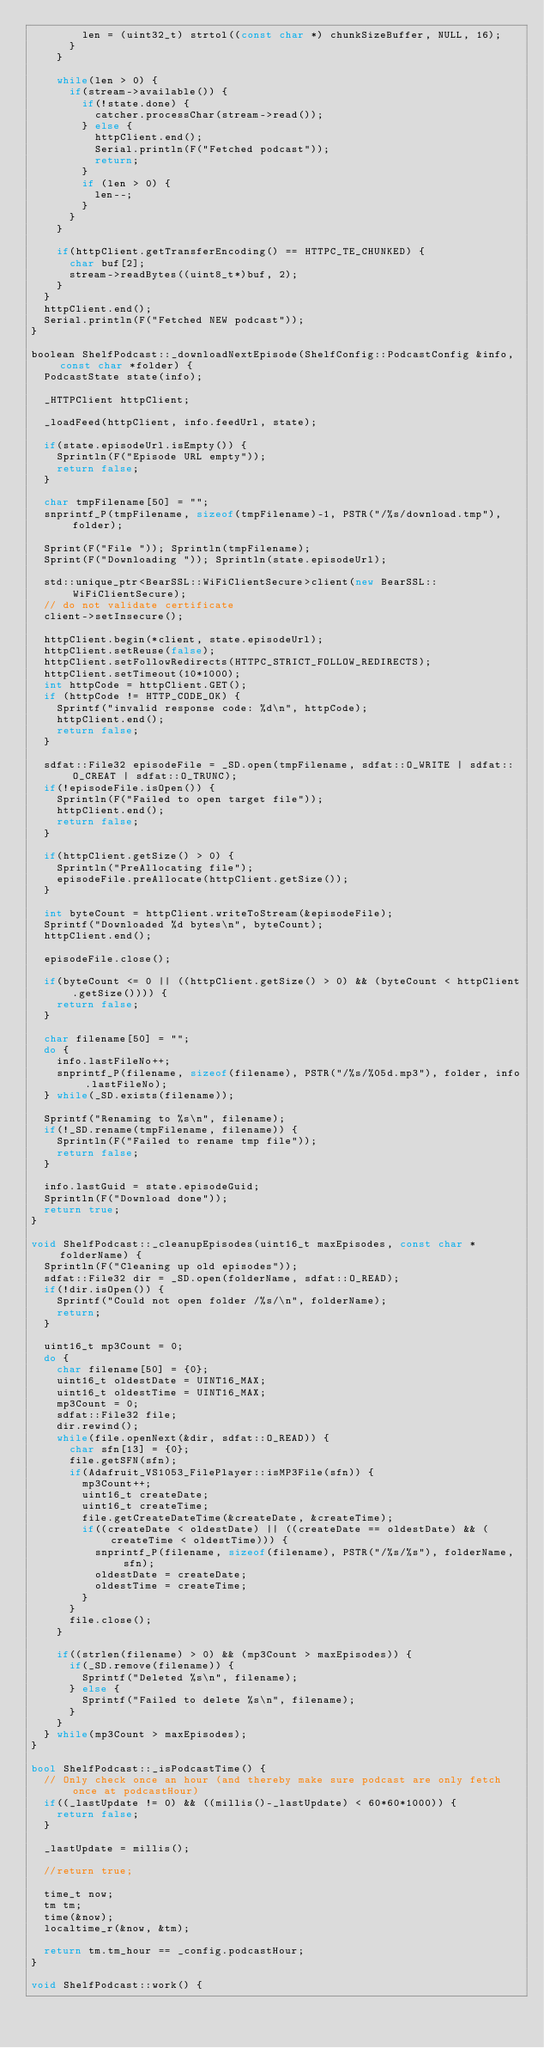Convert code to text. <code><loc_0><loc_0><loc_500><loc_500><_C++_>        len = (uint32_t) strtol((const char *) chunkSizeBuffer, NULL, 16);
      }
    }

    while(len > 0) {
      if(stream->available()) {
        if(!state.done) {
          catcher.processChar(stream->read());
        } else {
          httpClient.end();
          Serial.println(F("Fetched podcast"));
          return;
        }
        if (len > 0) {
          len--;
        }
      }
    }

    if(httpClient.getTransferEncoding() == HTTPC_TE_CHUNKED) {
      char buf[2];
      stream->readBytes((uint8_t*)buf, 2);
    }
  }
  httpClient.end();
  Serial.println(F("Fetched NEW podcast"));
}

boolean ShelfPodcast::_downloadNextEpisode(ShelfConfig::PodcastConfig &info, const char *folder) {
  PodcastState state(info);

  _HTTPClient httpClient;

  _loadFeed(httpClient, info.feedUrl, state);

  if(state.episodeUrl.isEmpty()) {
    Sprintln(F("Episode URL empty"));
    return false;
  }

  char tmpFilename[50] = "";
  snprintf_P(tmpFilename, sizeof(tmpFilename)-1, PSTR("/%s/download.tmp"), folder);

  Sprint(F("File ")); Sprintln(tmpFilename);
  Sprint(F("Downloading ")); Sprintln(state.episodeUrl);

  std::unique_ptr<BearSSL::WiFiClientSecure>client(new BearSSL::WiFiClientSecure);
  // do not validate certificate
  client->setInsecure();

  httpClient.begin(*client, state.episodeUrl);
  httpClient.setReuse(false);
  httpClient.setFollowRedirects(HTTPC_STRICT_FOLLOW_REDIRECTS);
  httpClient.setTimeout(10*1000);
  int httpCode = httpClient.GET();
  if (httpCode != HTTP_CODE_OK) {
    Sprintf("invalid response code: %d\n", httpCode);
    httpClient.end();
    return false;
  }

  sdfat::File32 episodeFile = _SD.open(tmpFilename, sdfat::O_WRITE | sdfat::O_CREAT | sdfat::O_TRUNC);
  if(!episodeFile.isOpen()) {
    Sprintln(F("Failed to open target file"));
    httpClient.end();
    return false;
  }

  if(httpClient.getSize() > 0) {
    Sprintln("PreAllocating file");
    episodeFile.preAllocate(httpClient.getSize());
  }

  int byteCount = httpClient.writeToStream(&episodeFile);
  Sprintf("Downloaded %d bytes\n", byteCount);
  httpClient.end();

  episodeFile.close();

  if(byteCount <= 0 || ((httpClient.getSize() > 0) && (byteCount < httpClient.getSize()))) {
    return false;
  }

  char filename[50] = "";
  do {
    info.lastFileNo++;
    snprintf_P(filename, sizeof(filename), PSTR("/%s/%05d.mp3"), folder, info.lastFileNo);
  } while(_SD.exists(filename));

  Sprintf("Renaming to %s\n", filename);
  if(!_SD.rename(tmpFilename, filename)) {
    Sprintln(F("Failed to rename tmp file"));
    return false;
  }

  info.lastGuid = state.episodeGuid;
  Sprintln(F("Download done"));
  return true;
}

void ShelfPodcast::_cleanupEpisodes(uint16_t maxEpisodes, const char *folderName) {
  Sprintln(F("Cleaning up old episodes"));
  sdfat::File32 dir = _SD.open(folderName, sdfat::O_READ);
  if(!dir.isOpen()) {
    Sprintf("Could not open folder /%s/\n", folderName);
    return;
  }

  uint16_t mp3Count = 0;
  do {
    char filename[50] = {0};
    uint16_t oldestDate = UINT16_MAX;
    uint16_t oldestTime = UINT16_MAX;
    mp3Count = 0;
    sdfat::File32 file;
    dir.rewind();
    while(file.openNext(&dir, sdfat::O_READ)) {
      char sfn[13] = {0};
      file.getSFN(sfn);
      if(Adafruit_VS1053_FilePlayer::isMP3File(sfn)) {
        mp3Count++;
        uint16_t createDate;
        uint16_t createTime;
        file.getCreateDateTime(&createDate, &createTime);
        if((createDate < oldestDate) || ((createDate == oldestDate) && (createTime < oldestTime))) {
          snprintf_P(filename, sizeof(filename), PSTR("/%s/%s"), folderName, sfn);
          oldestDate = createDate;
          oldestTime = createTime;
        }
      }
      file.close();
    }

    if((strlen(filename) > 0) && (mp3Count > maxEpisodes)) {
      if(_SD.remove(filename)) {
        Sprintf("Deleted %s\n", filename);
      } else {
        Sprintf("Failed to delete %s\n", filename);
      }
    }
  } while(mp3Count > maxEpisodes);
}

bool ShelfPodcast::_isPodcastTime() {
  // Only check once an hour (and thereby make sure podcast are only fetch once at podcastHour)
  if((_lastUpdate != 0) && ((millis()-_lastUpdate) < 60*60*1000)) {
    return false;
  }

  _lastUpdate = millis();

  //return true;

  time_t now;
  tm tm;
  time(&now);
  localtime_r(&now, &tm);

  return tm.tm_hour == _config.podcastHour;
}

void ShelfPodcast::work() {</code> 